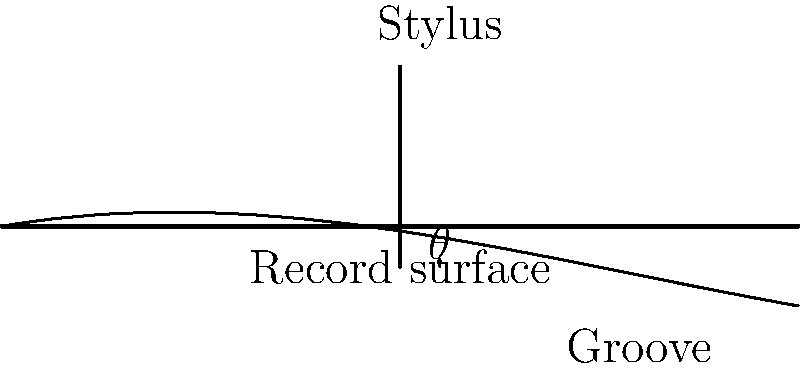As a radio host showcasing vinyl records of emerging Parisian artists, you're intrigued by the physics behind vinyl playback. In the diagram, a stylus is shown tracking a groove on a vinyl record. If the groove angle $\theta$ is 10°, what is the ideal tracking force angle for the stylus to minimize wear on both the stylus and the record? To determine the ideal tracking force angle for the stylus, we need to consider the principles of force distribution and friction minimization. Here's a step-by-step explanation:

1. The groove angle $\theta$ is given as 10°.

2. For optimal tracking and minimal wear, the stylus should apply equal force to both walls of the groove.

3. To achieve this, the tracking force should bisect the angle formed by the two walls of the groove.

4. The groove forms a V-shape, with each wall at an angle of $\theta$ to the vertical.

5. The total angle between the two walls is $2\theta = 2 \times 10° = 20°$.

6. To bisect this angle, we need to divide it by 2:
   $\frac{20°}{2} = 10°$

7. Therefore, the ideal tracking force angle should be 10° from vertical, which coincides with the groove angle $\theta$.

This angle ensures that the stylus applies equal pressure to both walls of the groove, minimizing wear and optimizing sound reproduction.
Answer: 10° 